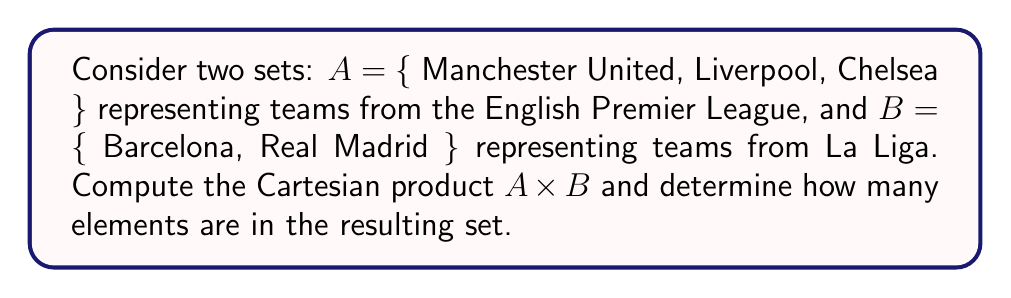Help me with this question. To solve this problem, we need to follow these steps:

1) Recall that the Cartesian product of two sets $A$ and $B$, denoted as $A \times B$, is the set of all ordered pairs $(a,b)$ where $a \in A$ and $b \in B$.

2) Let's list out all possible ordered pairs:
   - (Manchester United, Barcelona)
   - (Manchester United, Real Madrid)
   - (Liverpool, Barcelona)
   - (Liverpool, Real Madrid)
   - (Chelsea, Barcelona)
   - (Chelsea, Real Madrid)

3) To determine the number of elements in $A \times B$, we can use the multiplication principle:
   $$|A \times B| = |A| \cdot |B|$$
   
   Where $|A|$ represents the number of elements in set $A$, and $|B|$ represents the number of elements in set $B$.

4) In this case:
   $|A| = 3$ (Manchester United, Liverpool, Chelsea)
   $|B| = 2$ (Barcelona, Real Madrid)

5) Therefore:
   $$|A \times B| = 3 \cdot 2 = 6$$

This matches the number of ordered pairs we listed in step 2.
Answer: The Cartesian product $A \times B$ contains 6 elements. 